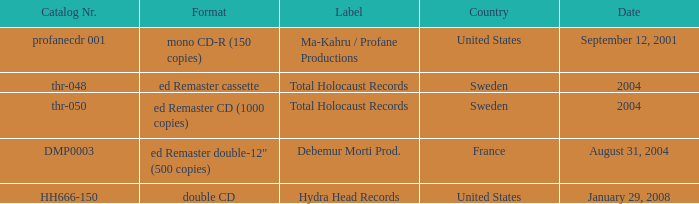Which country has the catalog nr of thr-048 in 2004? Sweden. 